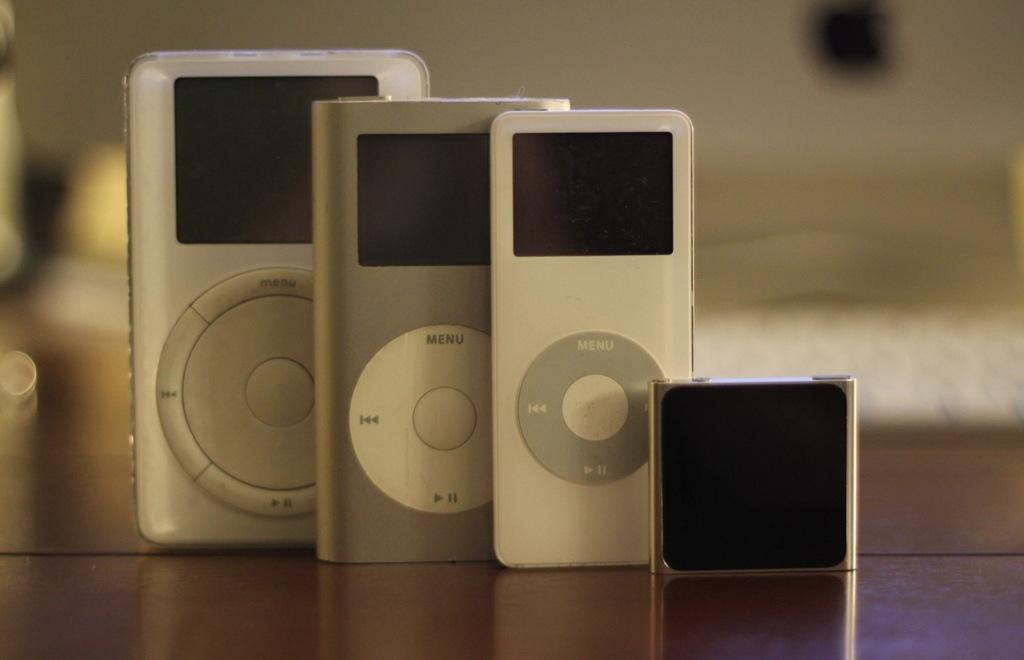Provide a one-sentence caption for the provided image. Three mp3 players have a menu button on the front. 